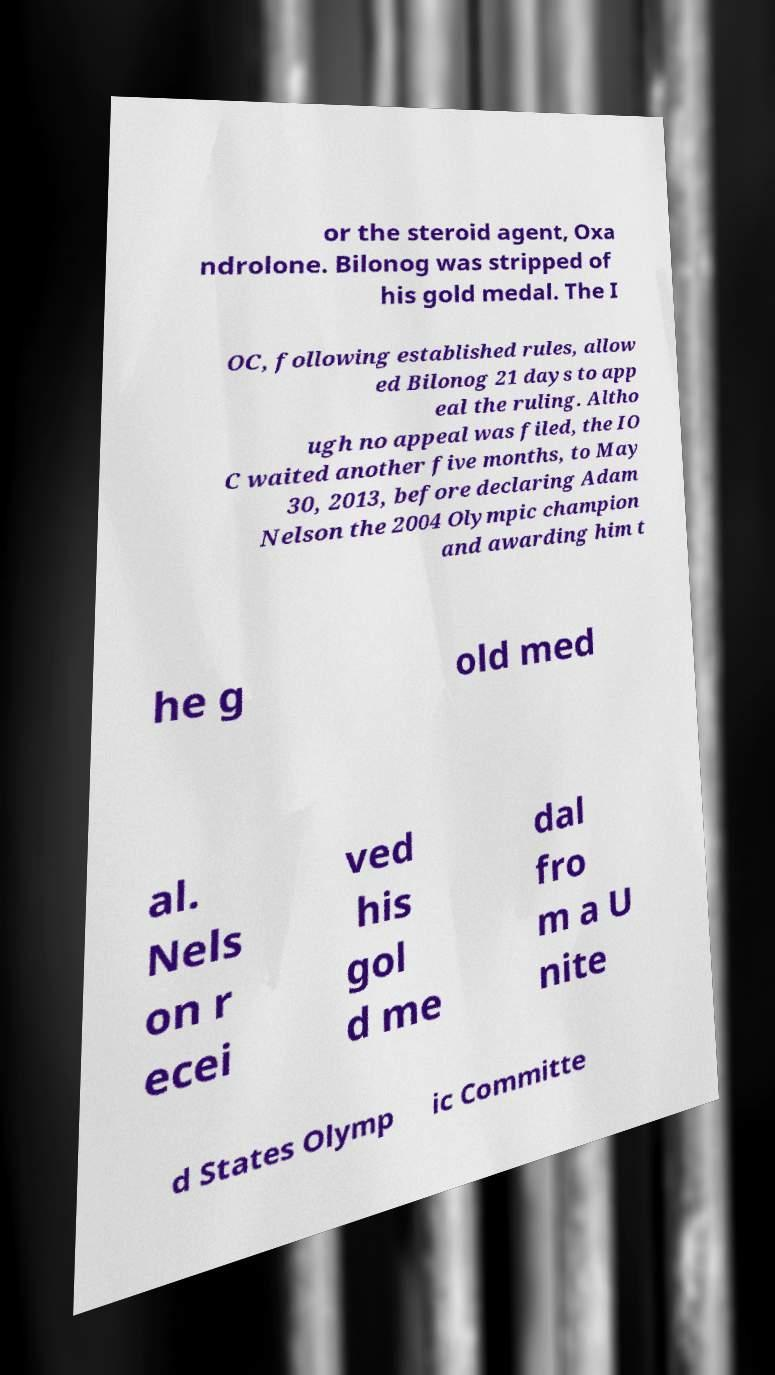Could you extract and type out the text from this image? or the steroid agent, Oxa ndrolone. Bilonog was stripped of his gold medal. The I OC, following established rules, allow ed Bilonog 21 days to app eal the ruling. Altho ugh no appeal was filed, the IO C waited another five months, to May 30, 2013, before declaring Adam Nelson the 2004 Olympic champion and awarding him t he g old med al. Nels on r ecei ved his gol d me dal fro m a U nite d States Olymp ic Committe 